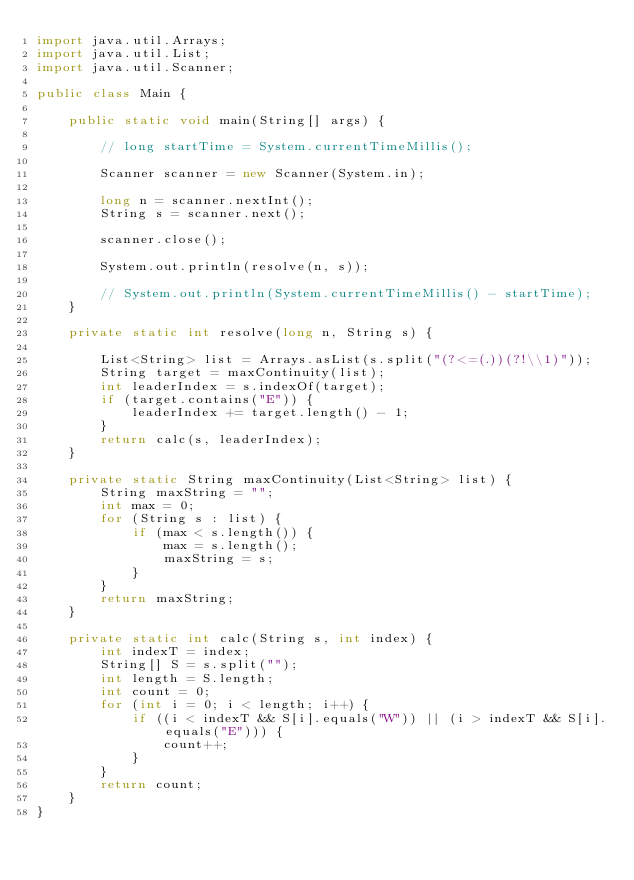<code> <loc_0><loc_0><loc_500><loc_500><_Java_>import java.util.Arrays;
import java.util.List;
import java.util.Scanner;

public class Main {

    public static void main(String[] args) {

        // long startTime = System.currentTimeMillis();

        Scanner scanner = new Scanner(System.in);

        long n = scanner.nextInt();
        String s = scanner.next();

        scanner.close();

        System.out.println(resolve(n, s));

        // System.out.println(System.currentTimeMillis() - startTime);
    }

    private static int resolve(long n, String s) {

        List<String> list = Arrays.asList(s.split("(?<=(.))(?!\\1)"));
        String target = maxContinuity(list);
        int leaderIndex = s.indexOf(target);
        if (target.contains("E")) {
            leaderIndex += target.length() - 1;
        }
        return calc(s, leaderIndex);
    }

    private static String maxContinuity(List<String> list) {
        String maxString = "";
        int max = 0;
        for (String s : list) {
            if (max < s.length()) {
                max = s.length();
                maxString = s;
            }
        }
        return maxString;
    }

    private static int calc(String s, int index) {
        int indexT = index;
        String[] S = s.split("");
        int length = S.length;
        int count = 0;
        for (int i = 0; i < length; i++) {
            if ((i < indexT && S[i].equals("W")) || (i > indexT && S[i].equals("E"))) {
                count++;
            }
        }
        return count;
    }
}</code> 